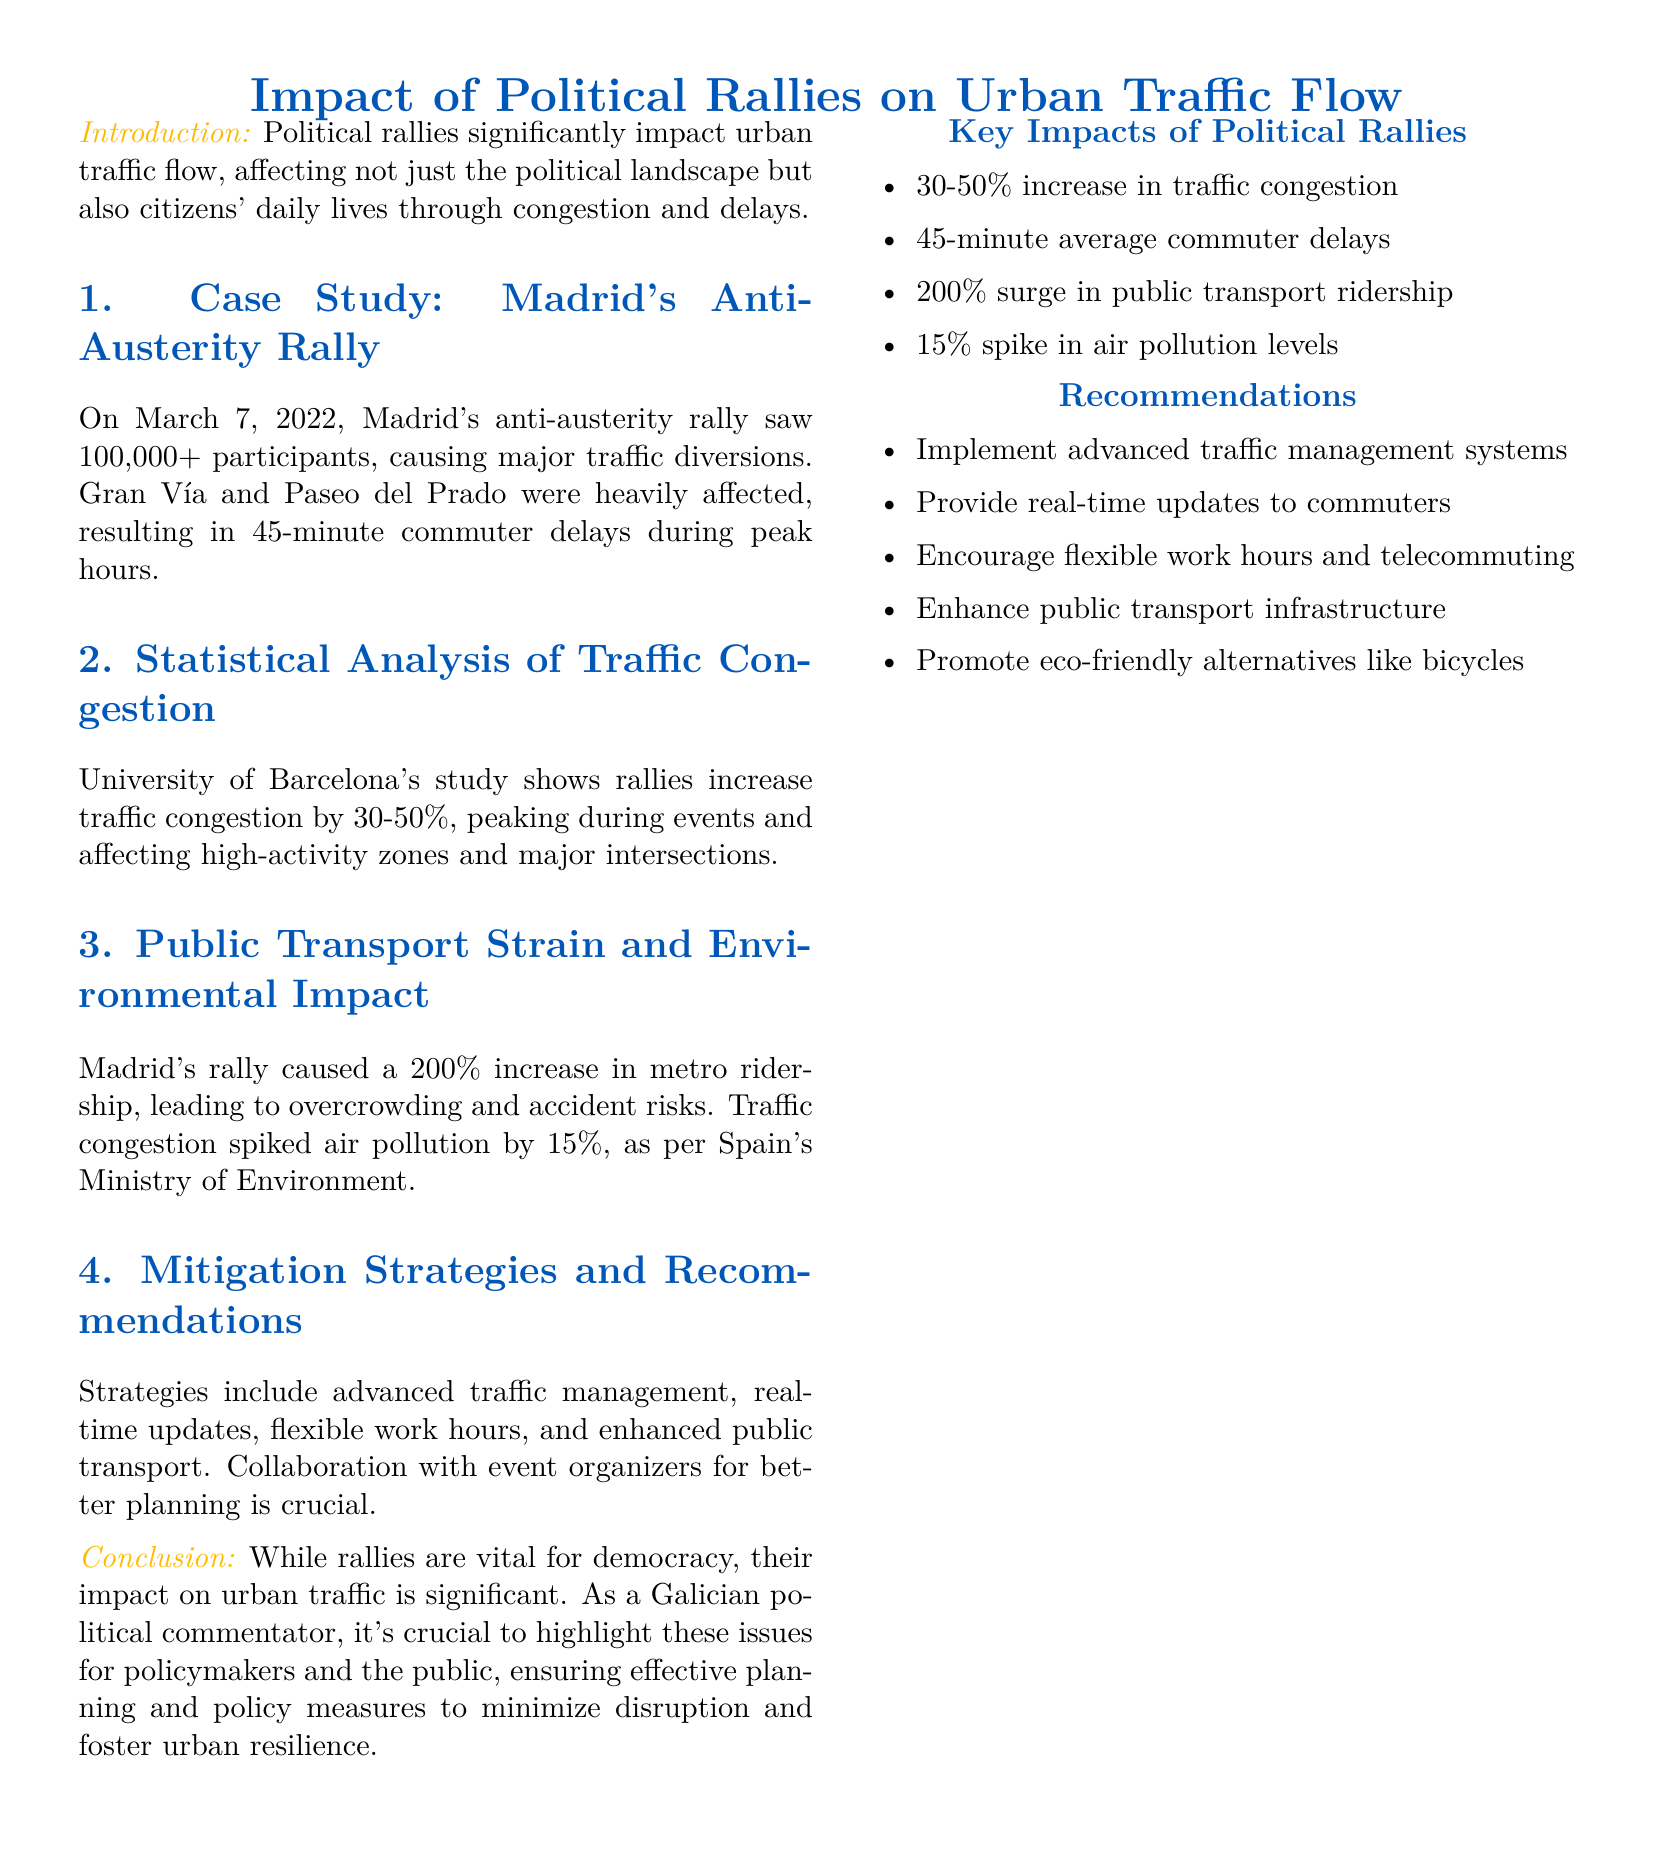What was the date of the Madrid anti-austerity rally? The document states that the Madrid anti-austerity rally occurred on March 7, 2022.
Answer: March 7, 2022 How many participants were at the Madrid rally? According to the document, the Madrid anti-austerity rally saw over 100,000 participants.
Answer: 100,000+ What was the average commuter delay during the rally? The report indicates that commuters faced an average delay of 45 minutes.
Answer: 45 minutes What percentage increase in public transport ridership was noted during the Madrid rally? The document mentions a 200% increase in metro ridership during the rally.
Answer: 200% What is the peak increase in traffic congestion as noted in the document? The statistical analysis shows that rallies increase traffic congestion by 30-50%.
Answer: 30-50% What environmental impact did the rally have, according to the Spain's Ministry of Environment? The document specifies a 15% spike in air pollution levels due to the rally.
Answer: 15% What is a recommended strategy for mitigating the impact of political rallies on traffic? The document recommends implementing advanced traffic management systems as a mitigation strategy.
Answer: Advanced traffic management systems How did the rally affect major intersections? The document indicates that the rallies particularly affected major intersections and high-activity zones.
Answer: Major intersections What can be promoted as eco-friendly alternatives according to the recommendations? The report suggests promoting eco-friendly alternatives like bicycles.
Answer: Bicycles 